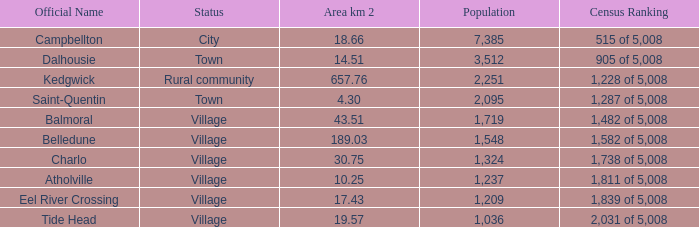When the communities name is Balmoral and the area is over 43.51 kilometers squared, what's the total population amount? 0.0. 